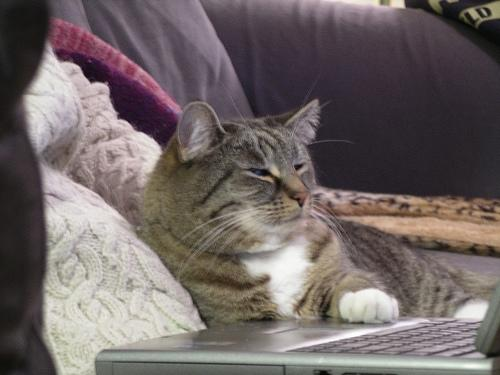What is similar to the long things on the animal's face?

Choices:
A) antenna
B) gills
C) unicorn horn
D) fins antenna 